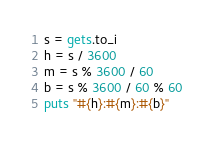Convert code to text. <code><loc_0><loc_0><loc_500><loc_500><_Ruby_>s = gets.to_i
h = s / 3600
m = s % 3600 / 60
b = s % 3600 / 60 % 60
puts "#{h}:#{m}:#{b}"
</code> 